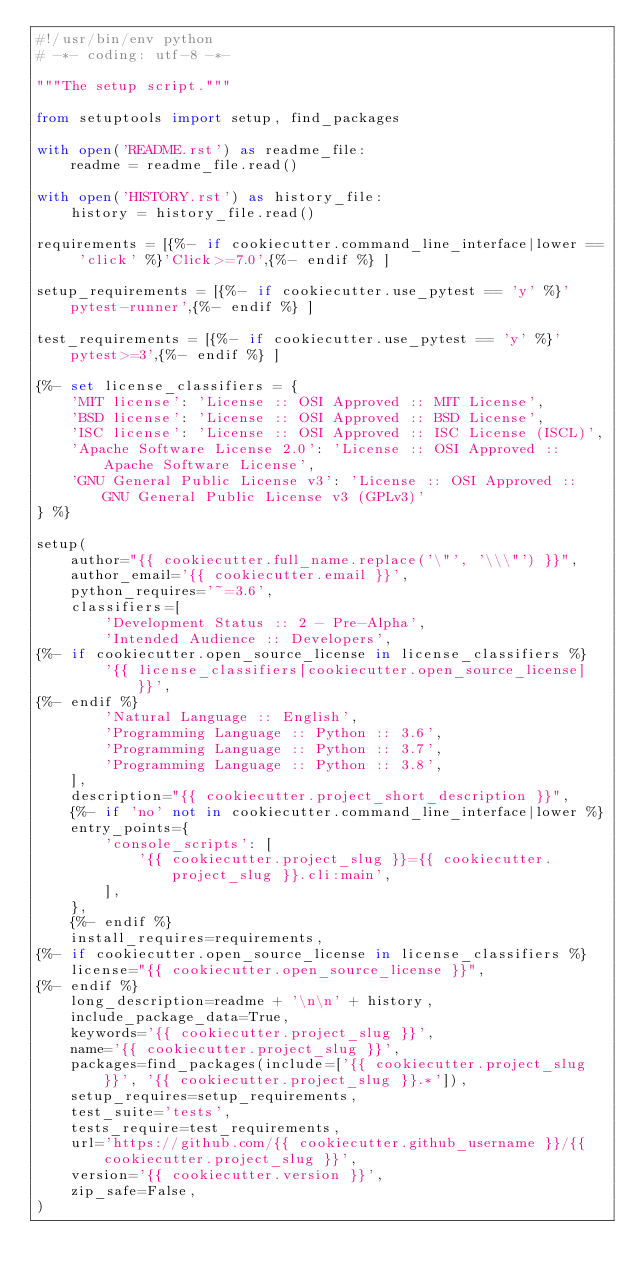<code> <loc_0><loc_0><loc_500><loc_500><_Python_>#!/usr/bin/env python
# -*- coding: utf-8 -*-

"""The setup script."""

from setuptools import setup, find_packages

with open('README.rst') as readme_file:
    readme = readme_file.read()

with open('HISTORY.rst') as history_file:
    history = history_file.read()

requirements = [{%- if cookiecutter.command_line_interface|lower == 'click' %}'Click>=7.0',{%- endif %} ]

setup_requirements = [{%- if cookiecutter.use_pytest == 'y' %}'pytest-runner',{%- endif %} ]

test_requirements = [{%- if cookiecutter.use_pytest == 'y' %}'pytest>=3',{%- endif %} ]

{%- set license_classifiers = {
    'MIT license': 'License :: OSI Approved :: MIT License',
    'BSD license': 'License :: OSI Approved :: BSD License',
    'ISC license': 'License :: OSI Approved :: ISC License (ISCL)',
    'Apache Software License 2.0': 'License :: OSI Approved :: Apache Software License',
    'GNU General Public License v3': 'License :: OSI Approved :: GNU General Public License v3 (GPLv3)'
} %}

setup(
    author="{{ cookiecutter.full_name.replace('\"', '\\\"') }}",
    author_email='{{ cookiecutter.email }}',
    python_requires='~=3.6',
    classifiers=[
        'Development Status :: 2 - Pre-Alpha',
        'Intended Audience :: Developers',
{%- if cookiecutter.open_source_license in license_classifiers %}
        '{{ license_classifiers[cookiecutter.open_source_license] }}',
{%- endif %}
        'Natural Language :: English',
        'Programming Language :: Python :: 3.6',
        'Programming Language :: Python :: 3.7',
        'Programming Language :: Python :: 3.8',
    ],
    description="{{ cookiecutter.project_short_description }}",
    {%- if 'no' not in cookiecutter.command_line_interface|lower %}
    entry_points={
        'console_scripts': [
            '{{ cookiecutter.project_slug }}={{ cookiecutter.project_slug }}.cli:main',
        ],
    },
    {%- endif %}
    install_requires=requirements,
{%- if cookiecutter.open_source_license in license_classifiers %}
    license="{{ cookiecutter.open_source_license }}",
{%- endif %}
    long_description=readme + '\n\n' + history,
    include_package_data=True,
    keywords='{{ cookiecutter.project_slug }}',
    name='{{ cookiecutter.project_slug }}',
    packages=find_packages(include=['{{ cookiecutter.project_slug }}', '{{ cookiecutter.project_slug }}.*']),
    setup_requires=setup_requirements,
    test_suite='tests',
    tests_require=test_requirements,
    url='https://github.com/{{ cookiecutter.github_username }}/{{ cookiecutter.project_slug }}',
    version='{{ cookiecutter.version }}',
    zip_safe=False,
)
</code> 